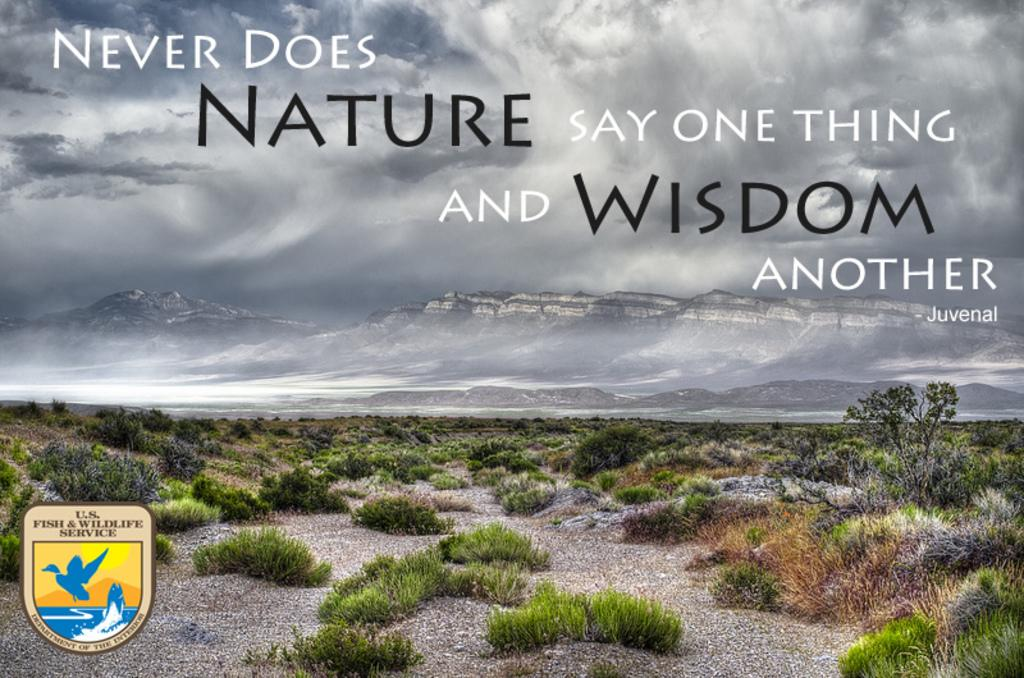What is the weather like in the image? The sky is cloudy in the image, indicating a potentially overcast or cloudy weather condition. What can be seen written or displayed in the image? There is something written on the image, which could be text or a message. What type of vegetation is visible in the image? There are plants visible in the image, which could be trees, bushes, or other forms of greenery. What geographical feature is visible in the distance? There are mountains in the distance, suggesting a landscape with elevated terrain. Where is the logo located in the image? The logo is in the left side corner of the image, indicating its position and prominence. How many trousers are hanging on the plants in the image? There are no trousers visible in the image; it features plants, a cloudy sky, mountains, and a logo. What is the amount of rainfall in the image? The image does not provide information about the amount of rainfall; it only shows a cloudy sky. 